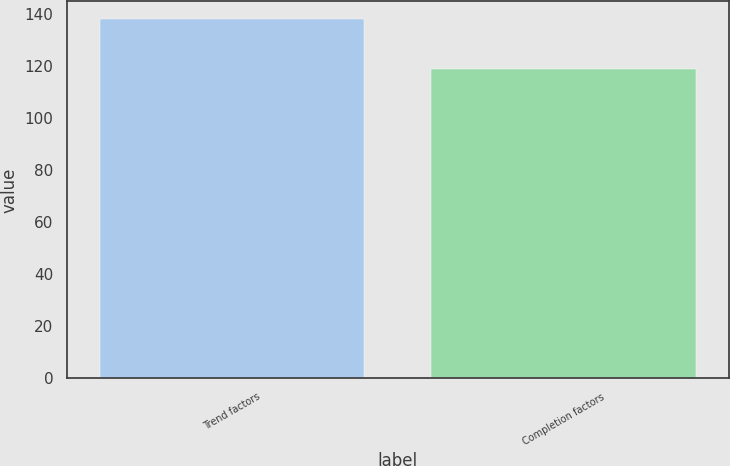<chart> <loc_0><loc_0><loc_500><loc_500><bar_chart><fcel>Trend factors<fcel>Completion factors<nl><fcel>138<fcel>119<nl></chart> 